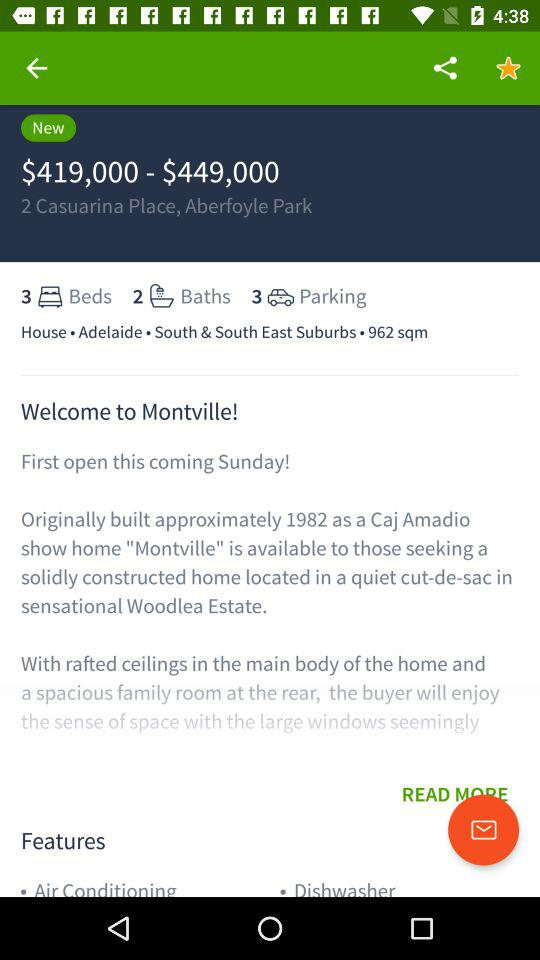How many square meters is the house? The house is 962 square meters. 